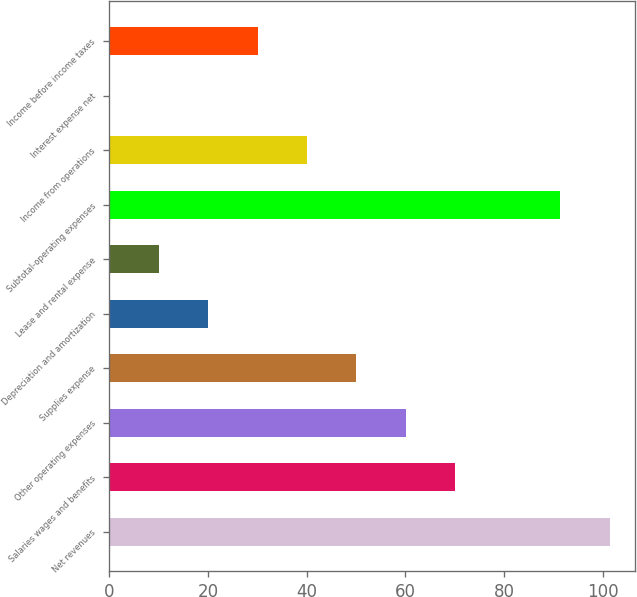Convert chart. <chart><loc_0><loc_0><loc_500><loc_500><bar_chart><fcel>Net revenues<fcel>Salaries wages and benefits<fcel>Other operating expenses<fcel>Supplies expense<fcel>Depreciation and amortization<fcel>Lease and rental expense<fcel>Subtotal-operating expenses<fcel>Income from operations<fcel>Interest expense net<fcel>Income before income taxes<nl><fcel>101.39<fcel>70.03<fcel>60.04<fcel>50.05<fcel>20.08<fcel>10.09<fcel>91.4<fcel>40.06<fcel>0.1<fcel>30.07<nl></chart> 